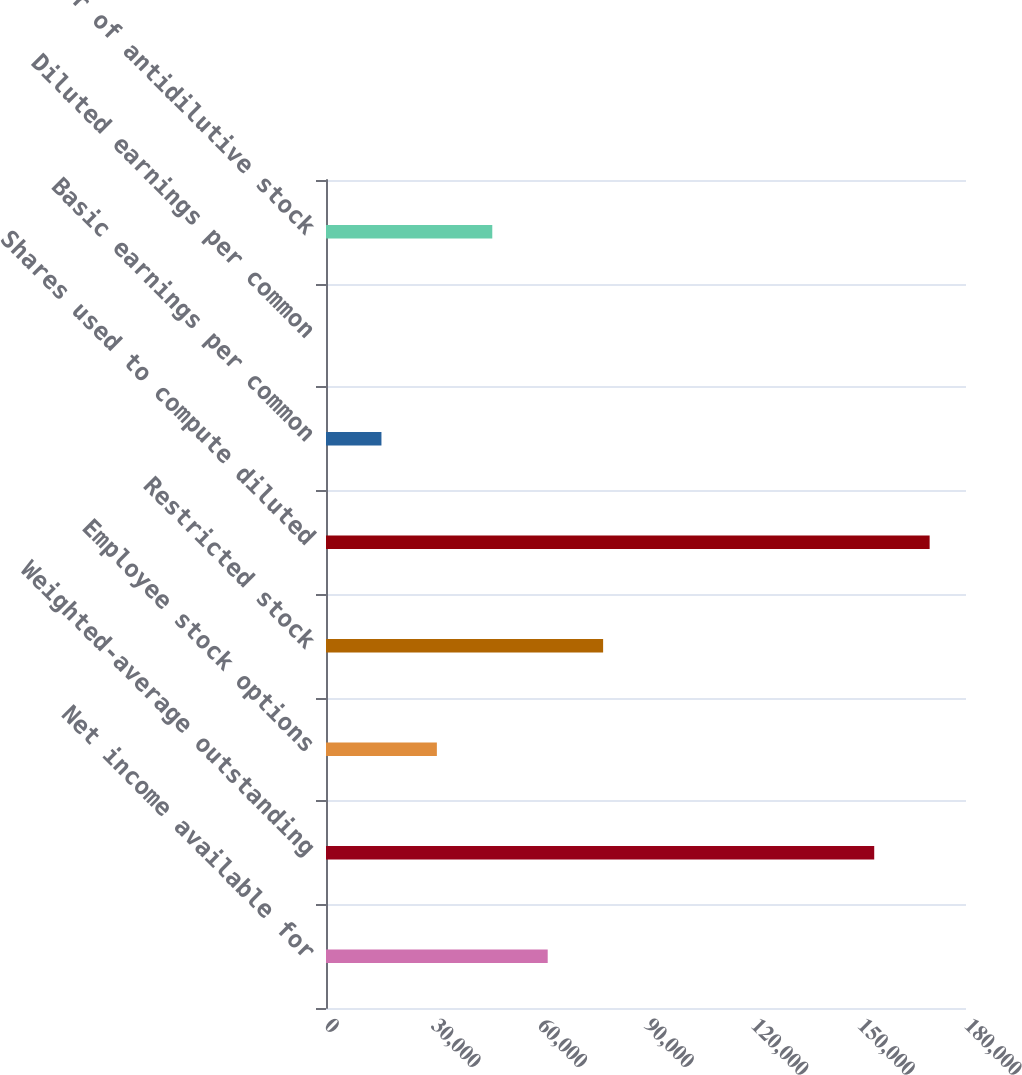<chart> <loc_0><loc_0><loc_500><loc_500><bar_chart><fcel>Net income available for<fcel>Weighted-average outstanding<fcel>Employee stock options<fcel>Restricted stock<fcel>Shares used to compute diluted<fcel>Basic earnings per common<fcel>Diluted earnings per common<fcel>Number of antidilutive stock<nl><fcel>62354<fcel>154187<fcel>31180.7<fcel>77940.7<fcel>169774<fcel>15594<fcel>7.36<fcel>46767.3<nl></chart> 